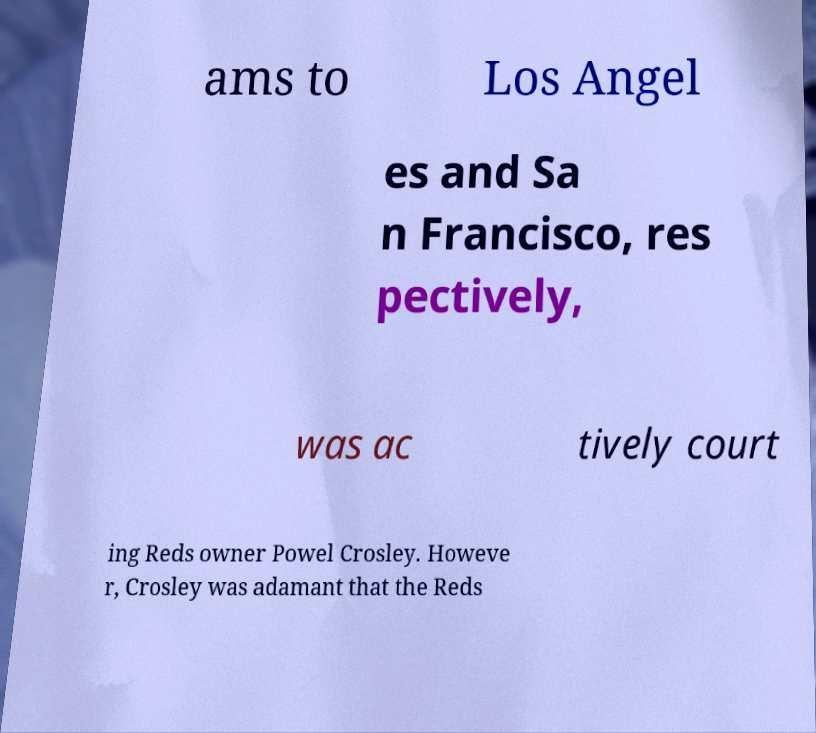Could you assist in decoding the text presented in this image and type it out clearly? ams to Los Angel es and Sa n Francisco, res pectively, was ac tively court ing Reds owner Powel Crosley. Howeve r, Crosley was adamant that the Reds 